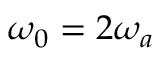Convert formula to latex. <formula><loc_0><loc_0><loc_500><loc_500>\omega _ { 0 } = 2 \omega _ { a }</formula> 